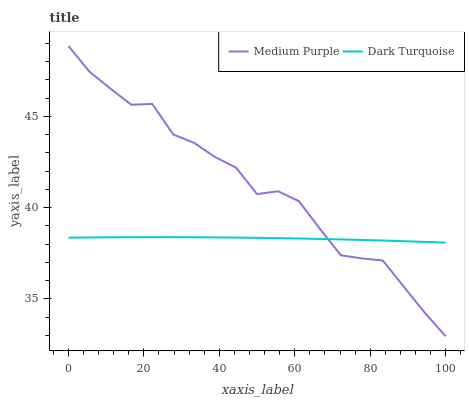Does Dark Turquoise have the minimum area under the curve?
Answer yes or no. Yes. Does Medium Purple have the maximum area under the curve?
Answer yes or no. Yes. Does Dark Turquoise have the maximum area under the curve?
Answer yes or no. No. Is Dark Turquoise the smoothest?
Answer yes or no. Yes. Is Medium Purple the roughest?
Answer yes or no. Yes. Is Dark Turquoise the roughest?
Answer yes or no. No. Does Medium Purple have the lowest value?
Answer yes or no. Yes. Does Dark Turquoise have the lowest value?
Answer yes or no. No. Does Medium Purple have the highest value?
Answer yes or no. Yes. Does Dark Turquoise have the highest value?
Answer yes or no. No. Does Medium Purple intersect Dark Turquoise?
Answer yes or no. Yes. Is Medium Purple less than Dark Turquoise?
Answer yes or no. No. Is Medium Purple greater than Dark Turquoise?
Answer yes or no. No. 